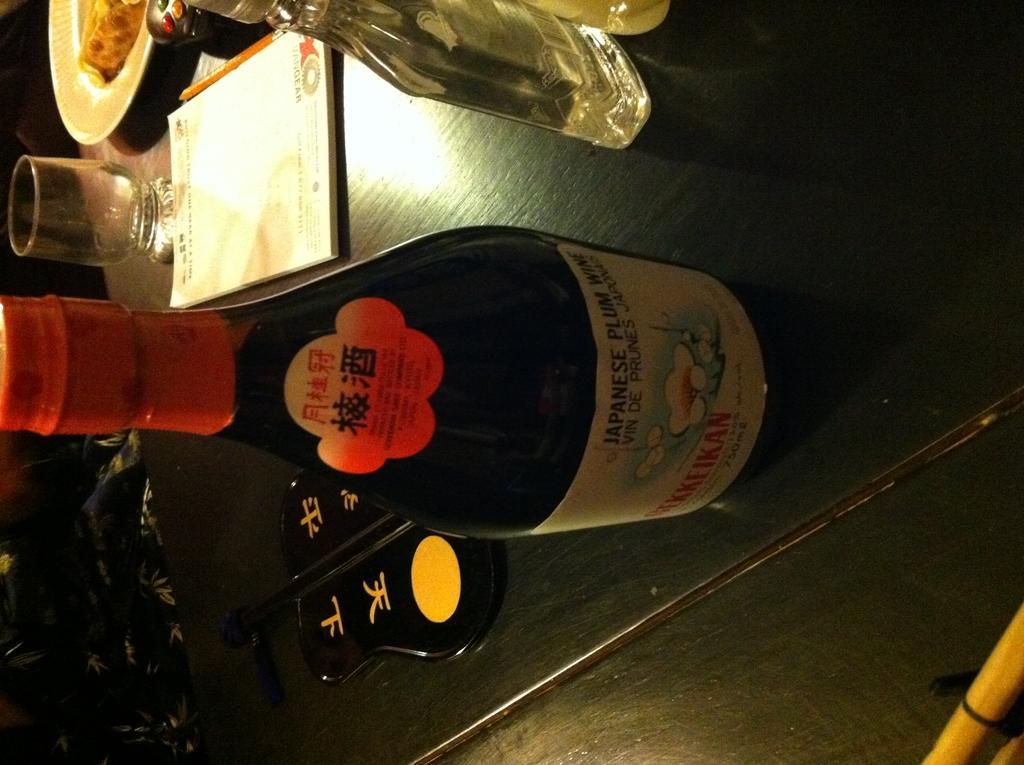Can you describe this image briefly? on the table there is a black bottle, a transparent glass bottle. behind that there is a book, pencil, plate. 